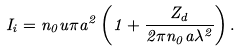<formula> <loc_0><loc_0><loc_500><loc_500>I _ { i } = n _ { 0 } u \pi a ^ { 2 } \left ( 1 + \frac { Z _ { d } } { 2 \pi n _ { 0 } a \lambda ^ { 2 } } \right ) .</formula> 